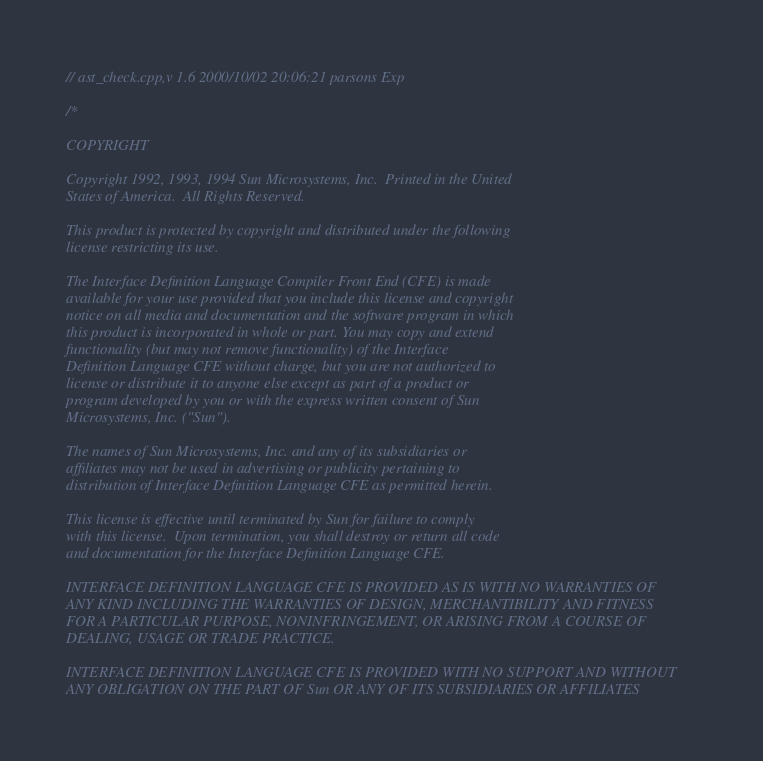<code> <loc_0><loc_0><loc_500><loc_500><_C++_>// ast_check.cpp,v 1.6 2000/10/02 20:06:21 parsons Exp

/*

COPYRIGHT

Copyright 1992, 1993, 1994 Sun Microsystems, Inc.  Printed in the United
States of America.  All Rights Reserved.

This product is protected by copyright and distributed under the following
license restricting its use.

The Interface Definition Language Compiler Front End (CFE) is made
available for your use provided that you include this license and copyright
notice on all media and documentation and the software program in which
this product is incorporated in whole or part. You may copy and extend
functionality (but may not remove functionality) of the Interface
Definition Language CFE without charge, but you are not authorized to
license or distribute it to anyone else except as part of a product or
program developed by you or with the express written consent of Sun
Microsystems, Inc. ("Sun").

The names of Sun Microsystems, Inc. and any of its subsidiaries or
affiliates may not be used in advertising or publicity pertaining to
distribution of Interface Definition Language CFE as permitted herein.

This license is effective until terminated by Sun for failure to comply
with this license.  Upon termination, you shall destroy or return all code
and documentation for the Interface Definition Language CFE.

INTERFACE DEFINITION LANGUAGE CFE IS PROVIDED AS IS WITH NO WARRANTIES OF
ANY KIND INCLUDING THE WARRANTIES OF DESIGN, MERCHANTIBILITY AND FITNESS
FOR A PARTICULAR PURPOSE, NONINFRINGEMENT, OR ARISING FROM A COURSE OF
DEALING, USAGE OR TRADE PRACTICE.

INTERFACE DEFINITION LANGUAGE CFE IS PROVIDED WITH NO SUPPORT AND WITHOUT
ANY OBLIGATION ON THE PART OF Sun OR ANY OF ITS SUBSIDIARIES OR AFFILIATES</code> 